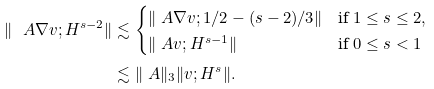Convert formula to latex. <formula><loc_0><loc_0><loc_500><loc_500>\| \ A \nabla v ; H ^ { s - 2 } \| & \lesssim \begin{cases} \| \ A \nabla v ; 1 / 2 - ( s - 2 ) / 3 \| & \text {if } 1 \leq s \leq 2 , \\ \| \ A v ; H ^ { s - 1 } \| & \text {if } 0 \leq s < 1 \end{cases} \\ & \lesssim \| \ A \| _ { 3 } \| v ; H ^ { s } \| .</formula> 